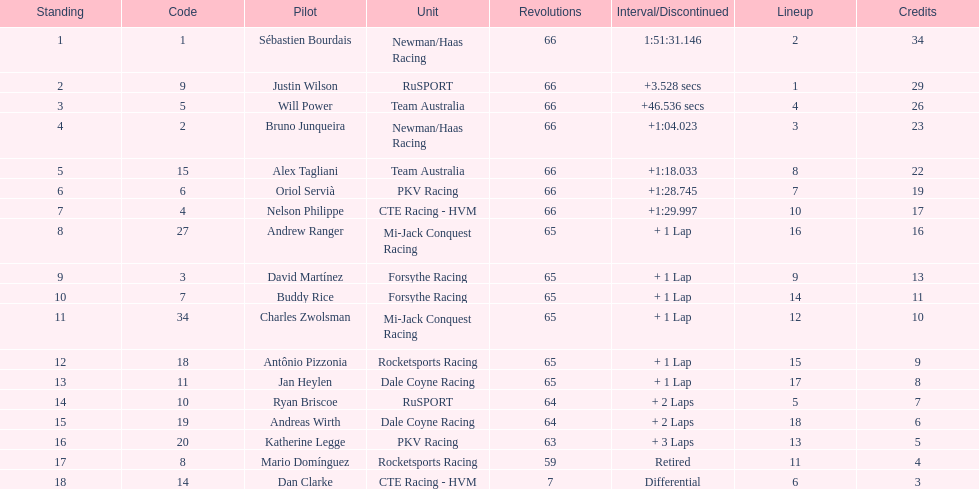Which country had more drivers representing them, the us or germany? Tie. 